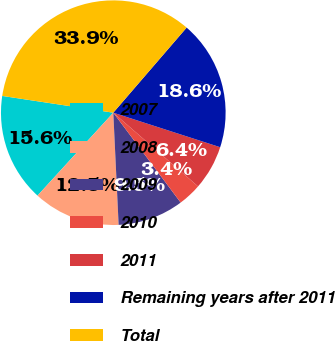Convert chart to OTSL. <chart><loc_0><loc_0><loc_500><loc_500><pie_chart><fcel>2007<fcel>2008<fcel>2009<fcel>2010<fcel>2011<fcel>Remaining years after 2011<fcel>Total<nl><fcel>15.6%<fcel>12.54%<fcel>9.48%<fcel>3.37%<fcel>6.42%<fcel>18.65%<fcel>33.94%<nl></chart> 